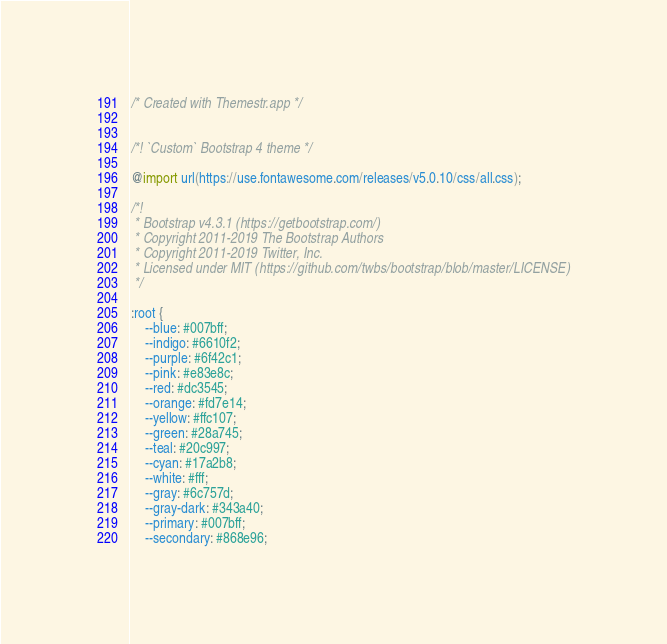Convert code to text. <code><loc_0><loc_0><loc_500><loc_500><_CSS_>/* Created with Themestr.app */


/*! `Custom` Bootstrap 4 theme */

@import url(https://use.fontawesome.com/releases/v5.0.10/css/all.css);

/*!
 * Bootstrap v4.3.1 (https://getbootstrap.com/)
 * Copyright 2011-2019 The Bootstrap Authors
 * Copyright 2011-2019 Twitter, Inc.
 * Licensed under MIT (https://github.com/twbs/bootstrap/blob/master/LICENSE)
 */

:root {
    --blue: #007bff;
    --indigo: #6610f2;
    --purple: #6f42c1;
    --pink: #e83e8c;
    --red: #dc3545;
    --orange: #fd7e14;
    --yellow: #ffc107;
    --green: #28a745;
    --teal: #20c997;
    --cyan: #17a2b8;
    --white: #fff;
    --gray: #6c757d;
    --gray-dark: #343a40;
    --primary: #007bff;
    --secondary: #868e96;</code> 